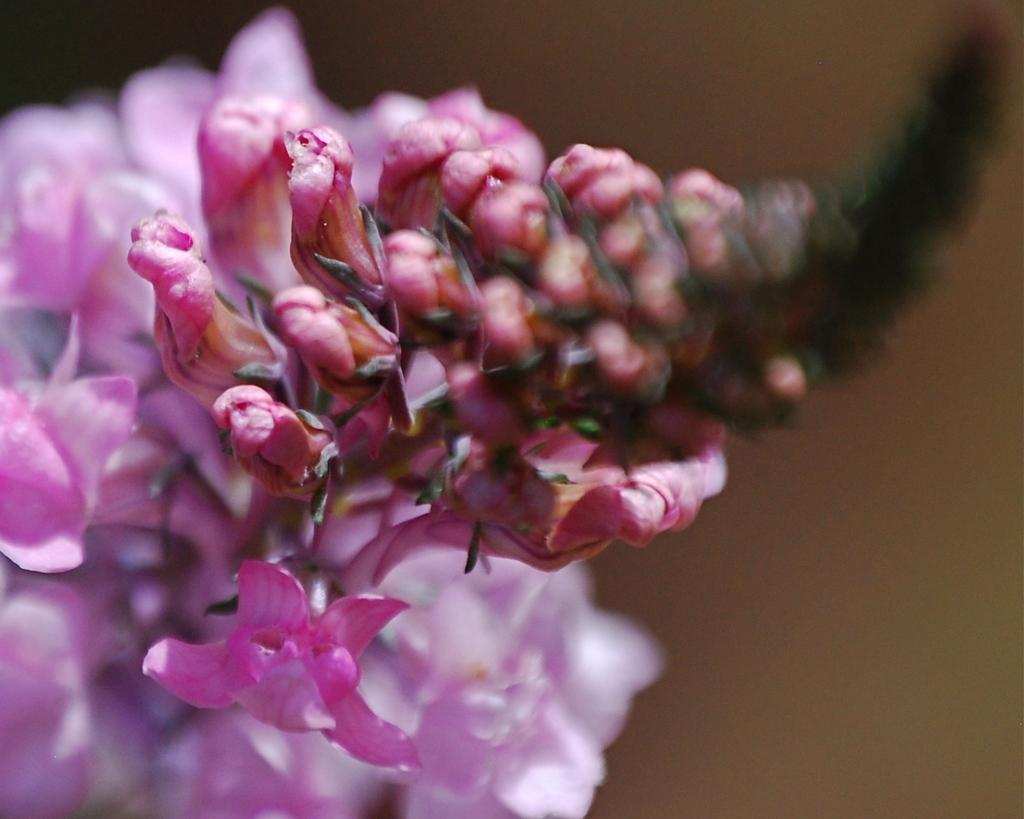What type of flowers can be seen in the image? There are pink flowers in the image. What is visible at the back side of the image? There is a wall visible at the back side of the image. How many arms are visible on the girls in the image? There are no girls present in the image, so there are no arms visible. 